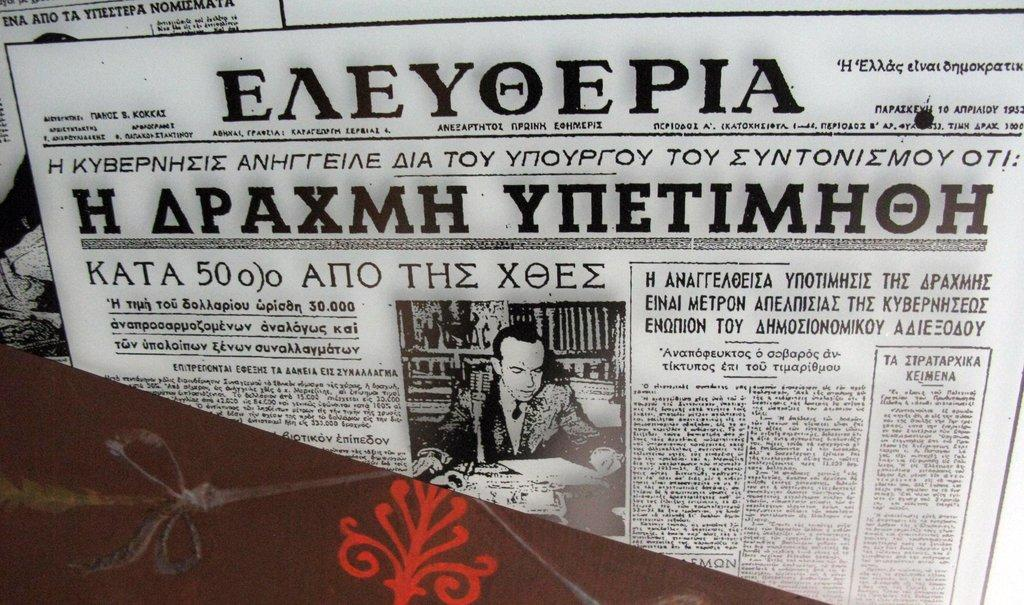What is the main object in the image? There is a paper in the image. What is written or printed on the paper? The paper contains text. Is there any visual element on the paper besides the text? Yes, the paper contains an image of a person. How much wealth does the plant in the image possess? There is no plant present in the image, so it is not possible to determine its wealth. 